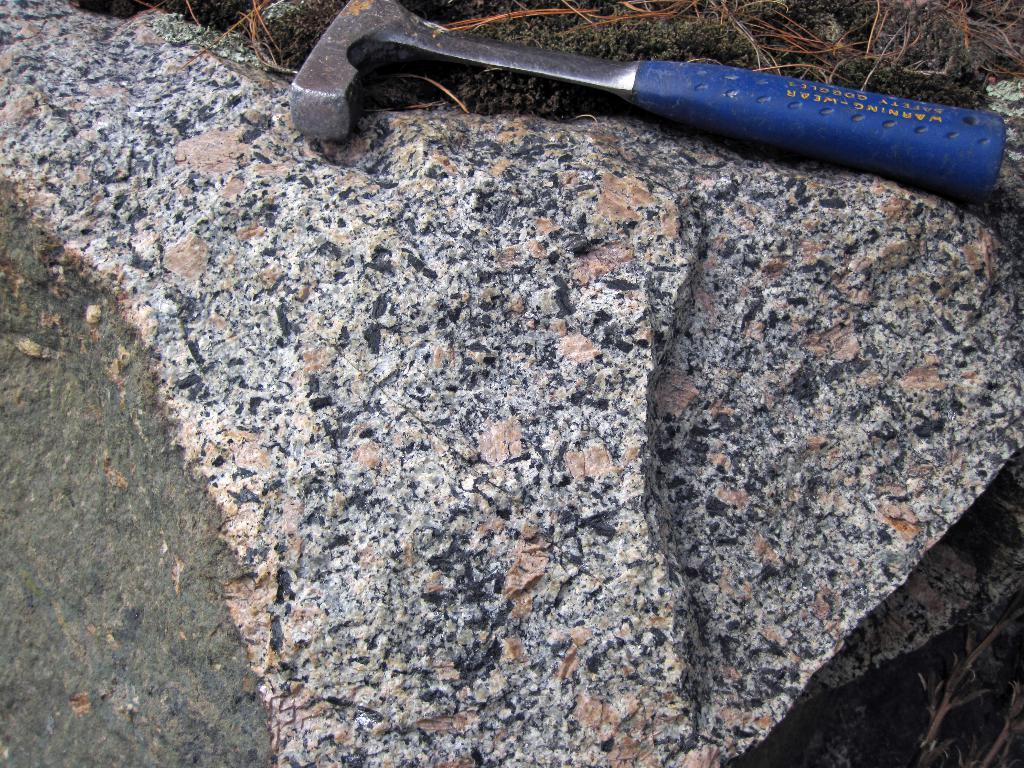Please provide a concise description of this image. In this picture we can see a hammer on rocks and in the background we can see grass. 